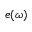Convert formula to latex. <formula><loc_0><loc_0><loc_500><loc_500>e ( \omega )</formula> 